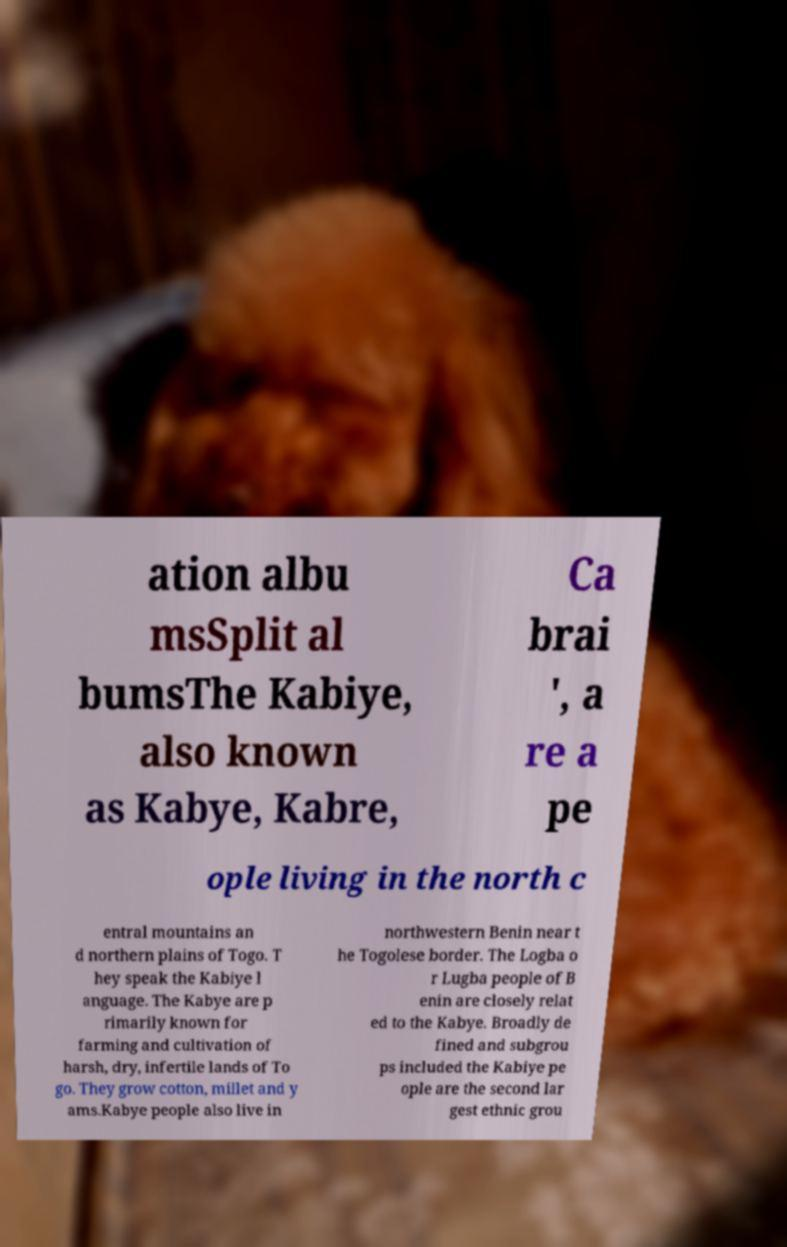For documentation purposes, I need the text within this image transcribed. Could you provide that? ation albu msSplit al bumsThe Kabiye, also known as Kabye, Kabre, Ca brai ', a re a pe ople living in the north c entral mountains an d northern plains of Togo. T hey speak the Kabiye l anguage. The Kabye are p rimarily known for farming and cultivation of harsh, dry, infertile lands of To go. They grow cotton, millet and y ams.Kabye people also live in northwestern Benin near t he Togolese border. The Logba o r Lugba people of B enin are closely relat ed to the Kabye. Broadly de fined and subgrou ps included the Kabiye pe ople are the second lar gest ethnic grou 